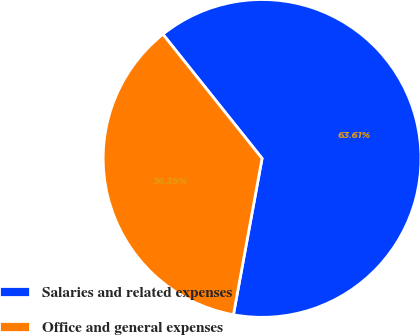<chart> <loc_0><loc_0><loc_500><loc_500><pie_chart><fcel>Salaries and related expenses<fcel>Office and general expenses<nl><fcel>63.61%<fcel>36.39%<nl></chart> 